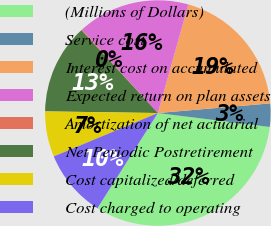<chart> <loc_0><loc_0><loc_500><loc_500><pie_chart><fcel>(Millions of Dollars)<fcel>Service cost<fcel>Interest cost on accumulated<fcel>Expected return on plan assets<fcel>Amortization of net actuarial<fcel>Net Periodic Postretirement<fcel>Cost capitalized/deferred<fcel>Cost charged to operating<nl><fcel>32.03%<fcel>3.33%<fcel>19.28%<fcel>16.09%<fcel>0.14%<fcel>12.9%<fcel>6.52%<fcel>9.71%<nl></chart> 